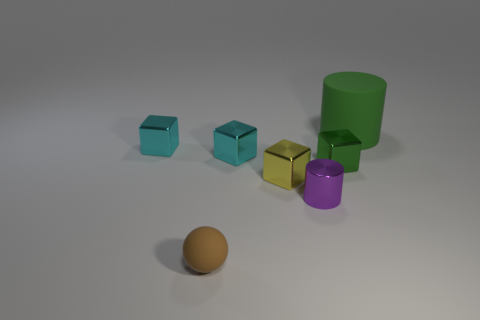Are there the same number of metal cylinders that are in front of the tiny purple thing and large gray matte cylinders?
Keep it short and to the point. Yes. What number of small spheres are made of the same material as the small brown thing?
Offer a terse response. 0. Are there fewer tiny matte things than tiny brown rubber cylinders?
Offer a terse response. No. Does the small cube that is to the left of the tiny matte thing have the same color as the big thing?
Give a very brief answer. No. How many cyan cubes are in front of the tiny cyan object that is to the left of the tiny brown rubber sphere in front of the small yellow block?
Give a very brief answer. 1. There is a small green cube; how many purple shiny cylinders are behind it?
Ensure brevity in your answer.  0. There is a metallic object that is the same shape as the big matte object; what is its color?
Your answer should be very brief. Purple. What material is the object that is both right of the small purple thing and in front of the green rubber object?
Your answer should be very brief. Metal. Does the matte thing on the right side of the brown matte object have the same size as the yellow block?
Make the answer very short. No. What material is the small brown object?
Make the answer very short. Rubber. 